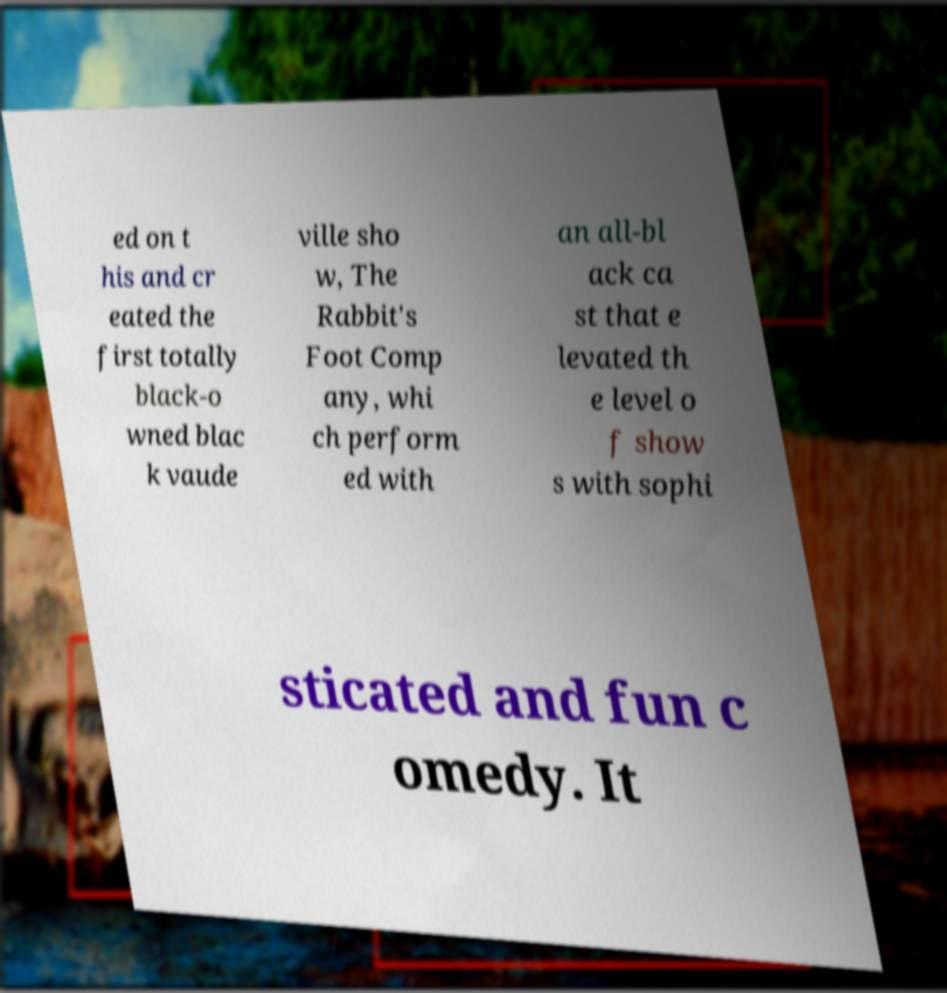Can you accurately transcribe the text from the provided image for me? ed on t his and cr eated the first totally black-o wned blac k vaude ville sho w, The Rabbit's Foot Comp any, whi ch perform ed with an all-bl ack ca st that e levated th e level o f show s with sophi sticated and fun c omedy. It 